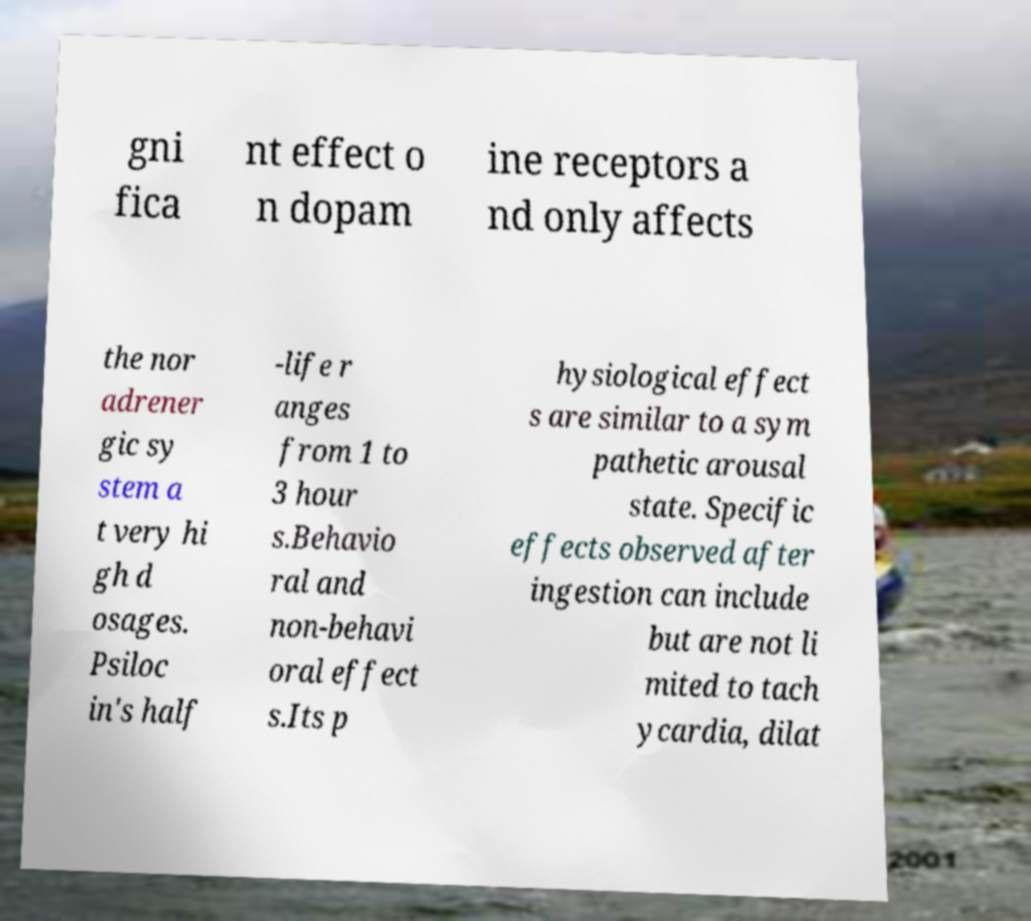Can you accurately transcribe the text from the provided image for me? gni fica nt effect o n dopam ine receptors a nd only affects the nor adrener gic sy stem a t very hi gh d osages. Psiloc in's half -life r anges from 1 to 3 hour s.Behavio ral and non-behavi oral effect s.Its p hysiological effect s are similar to a sym pathetic arousal state. Specific effects observed after ingestion can include but are not li mited to tach ycardia, dilat 